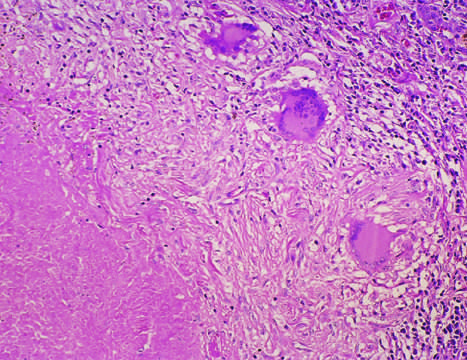s this the usual response in individuals who develop cell-mediated immunity to the organism?
Answer the question using a single word or phrase. Yes 